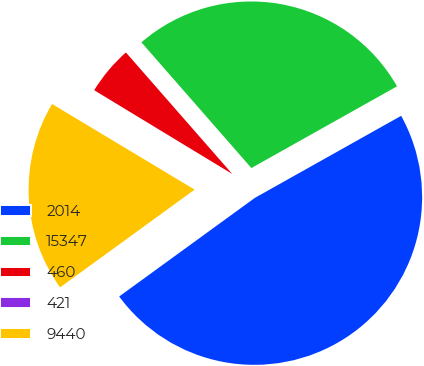Convert chart to OTSL. <chart><loc_0><loc_0><loc_500><loc_500><pie_chart><fcel>2014<fcel>15347<fcel>460<fcel>421<fcel>9440<nl><fcel>48.13%<fcel>28.3%<fcel>4.88%<fcel>0.07%<fcel>18.61%<nl></chart> 